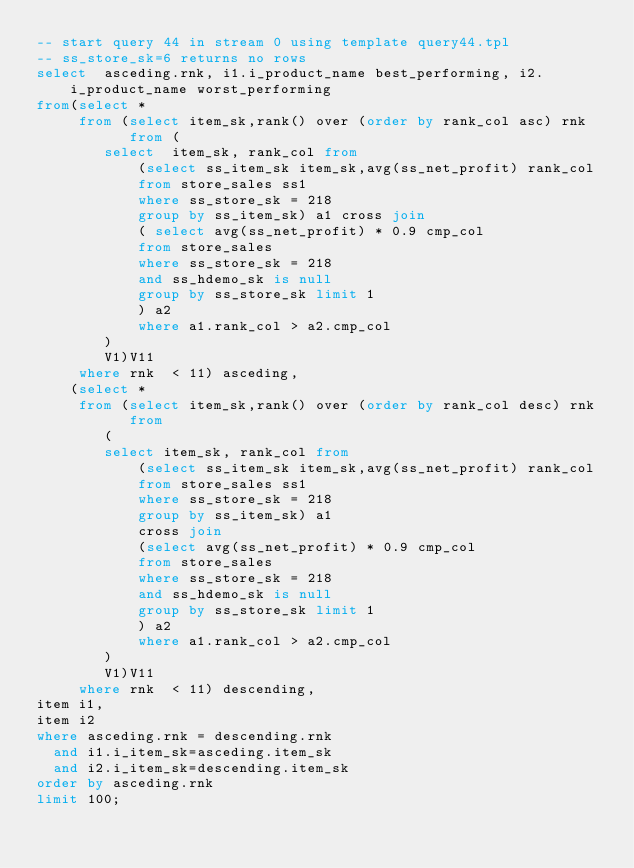Convert code to text. <code><loc_0><loc_0><loc_500><loc_500><_SQL_>-- start query 44 in stream 0 using template query44.tpl
-- ss_store_sk=6 returns no rows
select  asceding.rnk, i1.i_product_name best_performing, i2.i_product_name worst_performing
from(select *
     from (select item_sk,rank() over (order by rank_col asc) rnk
           from (
		select  item_sk, rank_col from 
			(select ss_item_sk item_sk,avg(ss_net_profit) rank_col
			from store_sales ss1
			where ss_store_sk = 218
			group by ss_item_sk) a1 cross join
			( select avg(ss_net_profit) * 0.9 cmp_col
  			from store_sales
  			where ss_store_sk = 218
  			and ss_hdemo_sk is null
 			group by ss_store_sk limit 1
 			) a2
  			where a1.rank_col > a2.cmp_col
		)
		V1)V11
     where rnk  < 11) asceding,
    (select *
     from (select item_sk,rank() over (order by rank_col desc) rnk
           from 
		(
		select item_sk, rank_col from 
			(select ss_item_sk item_sk,avg(ss_net_profit) rank_col
			from store_sales ss1
			where ss_store_sk = 218
			group by ss_item_sk) a1 
			cross join
			(select avg(ss_net_profit) * 0.9 cmp_col
  			from store_sales
  			where ss_store_sk = 218
  			and ss_hdemo_sk is null
  			group by ss_store_sk limit 1
 			) a2
 			where a1.rank_col > a2.cmp_col
		)
		V1)V11
     where rnk  < 11) descending,
item i1,
item i2
where asceding.rnk = descending.rnk
  and i1.i_item_sk=asceding.item_sk
  and i2.i_item_sk=descending.item_sk
order by asceding.rnk
limit 100;

</code> 